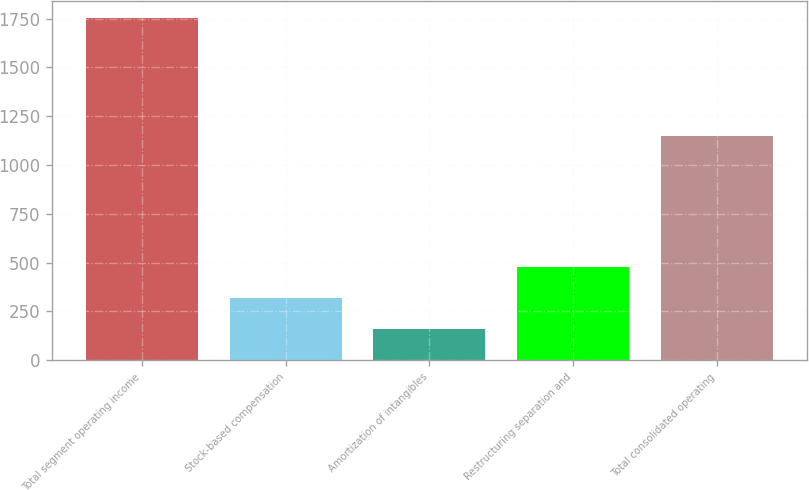Convert chart to OTSL. <chart><loc_0><loc_0><loc_500><loc_500><bar_chart><fcel>Total segment operating income<fcel>Stock-based compensation<fcel>Amortization of intangibles<fcel>Restructuring separation and<fcel>Total consolidated operating<nl><fcel>1755<fcel>318.6<fcel>159<fcel>478.2<fcel>1149<nl></chart> 